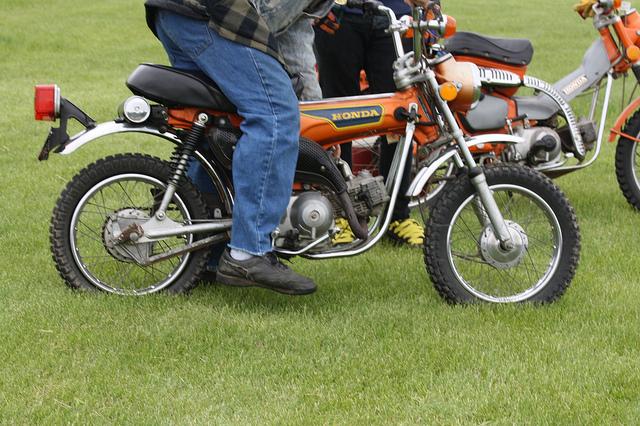What kind of motorcycle is closest?
Quick response, please. Honda. What color socks is the closest person wearing?
Quick response, please. White. What color is the grass?
Quick response, please. Green. 